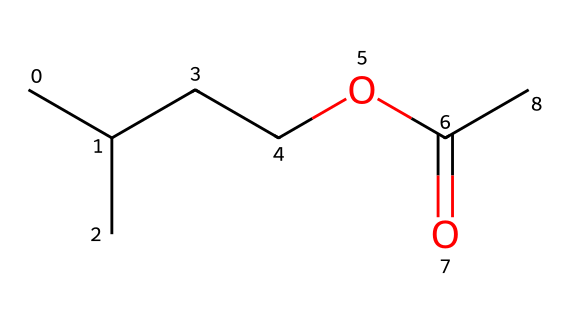What is the molecular formula of isoamyl acetate? The SMILES representation CC(C)CCOC(=O)C can be interpreted to identify the components that make up the molecule: it contains 5 carbon atoms (from CC(C)CC), 10 hydrogen atoms (counting the H connections), and 2 oxygen atoms (from O and OC(=O)). Thus, the molecular formula can be derived as C5H10O2.
Answer: C5H10O2 How many carbon atoms are there in isoamyl acetate? By analyzing the SMILES notation, we can count the number of carbon (C) atoms present. Notably, CC(C)CC indicates a total of 5 carbon atoms throughout the entire structure.
Answer: 5 What functional group is present in isoamyl acetate? The chemical structure includes the -COOC- linkage, which identifies it as an ester functional group. This is evident from the O=C and O connections in the SMILES notation.
Answer: ester What is the primary source of the banana flavor derived from isoamyl acetate? Isoamyl acetate is noted for its fruity flavor, particularly resembling that of bananas. This characteristic association is well-documented in sensory evaluations of food products containing this compound.
Answer: banana How many oxygen atoms are present in isoamyl acetate? In the SMILES representation, we can observe two oxygen atoms represented as O and OC(=O). Therefore, the total count of oxygen atoms is two.
Answer: 2 What type of chemical is isoamyl acetate classified as? Isoamyl acetate is classified as an ester, which is the general classification for this type of compound characterized by the presence of a carbonyl adjacent to an ether -COO- group as seen in the structure.
Answer: ester 